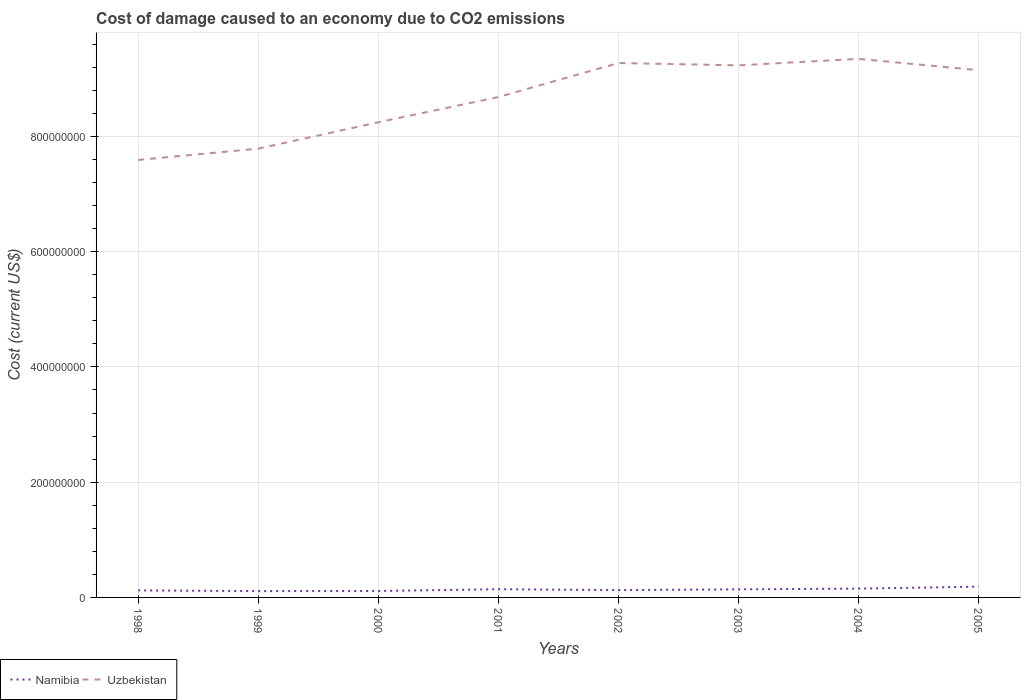How many different coloured lines are there?
Give a very brief answer. 2. Does the line corresponding to Namibia intersect with the line corresponding to Uzbekistan?
Make the answer very short. No. Across all years, what is the maximum cost of damage caused due to CO2 emissisons in Uzbekistan?
Provide a short and direct response. 7.59e+08. What is the total cost of damage caused due to CO2 emissisons in Namibia in the graph?
Provide a short and direct response. -1.26e+06. What is the difference between the highest and the second highest cost of damage caused due to CO2 emissisons in Uzbekistan?
Ensure brevity in your answer.  1.75e+08. What is the difference between the highest and the lowest cost of damage caused due to CO2 emissisons in Namibia?
Provide a succinct answer. 4. Is the cost of damage caused due to CO2 emissisons in Uzbekistan strictly greater than the cost of damage caused due to CO2 emissisons in Namibia over the years?
Your answer should be very brief. No. How many lines are there?
Make the answer very short. 2. How many years are there in the graph?
Offer a very short reply. 8. What is the difference between two consecutive major ticks on the Y-axis?
Ensure brevity in your answer.  2.00e+08. Does the graph contain any zero values?
Provide a short and direct response. No. Does the graph contain grids?
Make the answer very short. Yes. How many legend labels are there?
Your response must be concise. 2. What is the title of the graph?
Provide a succinct answer. Cost of damage caused to an economy due to CO2 emissions. Does "Sint Maarten (Dutch part)" appear as one of the legend labels in the graph?
Make the answer very short. No. What is the label or title of the X-axis?
Give a very brief answer. Years. What is the label or title of the Y-axis?
Provide a short and direct response. Cost (current US$). What is the Cost (current US$) in Namibia in 1998?
Provide a short and direct response. 1.22e+07. What is the Cost (current US$) in Uzbekistan in 1998?
Offer a very short reply. 7.59e+08. What is the Cost (current US$) in Namibia in 1999?
Keep it short and to the point. 1.10e+07. What is the Cost (current US$) in Uzbekistan in 1999?
Offer a terse response. 7.79e+08. What is the Cost (current US$) of Namibia in 2000?
Make the answer very short. 1.12e+07. What is the Cost (current US$) in Uzbekistan in 2000?
Make the answer very short. 8.25e+08. What is the Cost (current US$) of Namibia in 2001?
Keep it short and to the point. 1.42e+07. What is the Cost (current US$) in Uzbekistan in 2001?
Offer a very short reply. 8.68e+08. What is the Cost (current US$) of Namibia in 2002?
Your answer should be very brief. 1.27e+07. What is the Cost (current US$) of Uzbekistan in 2002?
Make the answer very short. 9.27e+08. What is the Cost (current US$) in Namibia in 2003?
Offer a very short reply. 1.40e+07. What is the Cost (current US$) of Uzbekistan in 2003?
Provide a short and direct response. 9.23e+08. What is the Cost (current US$) in Namibia in 2004?
Your answer should be very brief. 1.52e+07. What is the Cost (current US$) of Uzbekistan in 2004?
Provide a succinct answer. 9.35e+08. What is the Cost (current US$) in Namibia in 2005?
Make the answer very short. 1.87e+07. What is the Cost (current US$) in Uzbekistan in 2005?
Offer a very short reply. 9.15e+08. Across all years, what is the maximum Cost (current US$) of Namibia?
Provide a short and direct response. 1.87e+07. Across all years, what is the maximum Cost (current US$) of Uzbekistan?
Your response must be concise. 9.35e+08. Across all years, what is the minimum Cost (current US$) in Namibia?
Your answer should be very brief. 1.10e+07. Across all years, what is the minimum Cost (current US$) of Uzbekistan?
Your response must be concise. 7.59e+08. What is the total Cost (current US$) of Namibia in the graph?
Provide a short and direct response. 1.09e+08. What is the total Cost (current US$) of Uzbekistan in the graph?
Your answer should be compact. 6.93e+09. What is the difference between the Cost (current US$) in Namibia in 1998 and that in 1999?
Keep it short and to the point. 1.26e+06. What is the difference between the Cost (current US$) of Uzbekistan in 1998 and that in 1999?
Keep it short and to the point. -1.96e+07. What is the difference between the Cost (current US$) in Namibia in 1998 and that in 2000?
Your answer should be compact. 1.03e+06. What is the difference between the Cost (current US$) of Uzbekistan in 1998 and that in 2000?
Keep it short and to the point. -6.54e+07. What is the difference between the Cost (current US$) in Namibia in 1998 and that in 2001?
Give a very brief answer. -2.00e+06. What is the difference between the Cost (current US$) of Uzbekistan in 1998 and that in 2001?
Offer a terse response. -1.09e+08. What is the difference between the Cost (current US$) of Namibia in 1998 and that in 2002?
Provide a short and direct response. -5.26e+05. What is the difference between the Cost (current US$) in Uzbekistan in 1998 and that in 2002?
Ensure brevity in your answer.  -1.68e+08. What is the difference between the Cost (current US$) of Namibia in 1998 and that in 2003?
Offer a terse response. -1.78e+06. What is the difference between the Cost (current US$) of Uzbekistan in 1998 and that in 2003?
Offer a very short reply. -1.64e+08. What is the difference between the Cost (current US$) of Namibia in 1998 and that in 2004?
Your answer should be very brief. -3.02e+06. What is the difference between the Cost (current US$) of Uzbekistan in 1998 and that in 2004?
Your answer should be compact. -1.75e+08. What is the difference between the Cost (current US$) in Namibia in 1998 and that in 2005?
Provide a succinct answer. -6.51e+06. What is the difference between the Cost (current US$) of Uzbekistan in 1998 and that in 2005?
Your answer should be very brief. -1.56e+08. What is the difference between the Cost (current US$) in Namibia in 1999 and that in 2000?
Offer a very short reply. -2.31e+05. What is the difference between the Cost (current US$) in Uzbekistan in 1999 and that in 2000?
Your answer should be very brief. -4.57e+07. What is the difference between the Cost (current US$) of Namibia in 1999 and that in 2001?
Offer a terse response. -3.26e+06. What is the difference between the Cost (current US$) in Uzbekistan in 1999 and that in 2001?
Your answer should be very brief. -8.95e+07. What is the difference between the Cost (current US$) of Namibia in 1999 and that in 2002?
Offer a terse response. -1.79e+06. What is the difference between the Cost (current US$) of Uzbekistan in 1999 and that in 2002?
Ensure brevity in your answer.  -1.49e+08. What is the difference between the Cost (current US$) in Namibia in 1999 and that in 2003?
Provide a short and direct response. -3.04e+06. What is the difference between the Cost (current US$) in Uzbekistan in 1999 and that in 2003?
Your answer should be very brief. -1.45e+08. What is the difference between the Cost (current US$) in Namibia in 1999 and that in 2004?
Make the answer very short. -4.28e+06. What is the difference between the Cost (current US$) of Uzbekistan in 1999 and that in 2004?
Ensure brevity in your answer.  -1.56e+08. What is the difference between the Cost (current US$) of Namibia in 1999 and that in 2005?
Your answer should be compact. -7.77e+06. What is the difference between the Cost (current US$) of Uzbekistan in 1999 and that in 2005?
Give a very brief answer. -1.36e+08. What is the difference between the Cost (current US$) of Namibia in 2000 and that in 2001?
Your response must be concise. -3.03e+06. What is the difference between the Cost (current US$) in Uzbekistan in 2000 and that in 2001?
Your answer should be very brief. -4.38e+07. What is the difference between the Cost (current US$) in Namibia in 2000 and that in 2002?
Give a very brief answer. -1.55e+06. What is the difference between the Cost (current US$) in Uzbekistan in 2000 and that in 2002?
Make the answer very short. -1.03e+08. What is the difference between the Cost (current US$) in Namibia in 2000 and that in 2003?
Keep it short and to the point. -2.81e+06. What is the difference between the Cost (current US$) of Uzbekistan in 2000 and that in 2003?
Your response must be concise. -9.88e+07. What is the difference between the Cost (current US$) of Namibia in 2000 and that in 2004?
Offer a terse response. -4.05e+06. What is the difference between the Cost (current US$) in Uzbekistan in 2000 and that in 2004?
Your answer should be very brief. -1.10e+08. What is the difference between the Cost (current US$) of Namibia in 2000 and that in 2005?
Provide a succinct answer. -7.54e+06. What is the difference between the Cost (current US$) of Uzbekistan in 2000 and that in 2005?
Give a very brief answer. -9.04e+07. What is the difference between the Cost (current US$) of Namibia in 2001 and that in 2002?
Give a very brief answer. 1.47e+06. What is the difference between the Cost (current US$) of Uzbekistan in 2001 and that in 2002?
Offer a terse response. -5.90e+07. What is the difference between the Cost (current US$) of Namibia in 2001 and that in 2003?
Keep it short and to the point. 2.14e+05. What is the difference between the Cost (current US$) in Uzbekistan in 2001 and that in 2003?
Offer a very short reply. -5.50e+07. What is the difference between the Cost (current US$) in Namibia in 2001 and that in 2004?
Provide a succinct answer. -1.02e+06. What is the difference between the Cost (current US$) in Uzbekistan in 2001 and that in 2004?
Provide a short and direct response. -6.63e+07. What is the difference between the Cost (current US$) in Namibia in 2001 and that in 2005?
Keep it short and to the point. -4.51e+06. What is the difference between the Cost (current US$) of Uzbekistan in 2001 and that in 2005?
Ensure brevity in your answer.  -4.66e+07. What is the difference between the Cost (current US$) in Namibia in 2002 and that in 2003?
Provide a short and direct response. -1.26e+06. What is the difference between the Cost (current US$) in Uzbekistan in 2002 and that in 2003?
Your response must be concise. 4.01e+06. What is the difference between the Cost (current US$) in Namibia in 2002 and that in 2004?
Offer a terse response. -2.49e+06. What is the difference between the Cost (current US$) in Uzbekistan in 2002 and that in 2004?
Provide a short and direct response. -7.25e+06. What is the difference between the Cost (current US$) of Namibia in 2002 and that in 2005?
Provide a succinct answer. -5.98e+06. What is the difference between the Cost (current US$) in Uzbekistan in 2002 and that in 2005?
Provide a succinct answer. 1.24e+07. What is the difference between the Cost (current US$) in Namibia in 2003 and that in 2004?
Your response must be concise. -1.24e+06. What is the difference between the Cost (current US$) of Uzbekistan in 2003 and that in 2004?
Keep it short and to the point. -1.13e+07. What is the difference between the Cost (current US$) of Namibia in 2003 and that in 2005?
Your answer should be compact. -4.73e+06. What is the difference between the Cost (current US$) of Uzbekistan in 2003 and that in 2005?
Ensure brevity in your answer.  8.36e+06. What is the difference between the Cost (current US$) of Namibia in 2004 and that in 2005?
Keep it short and to the point. -3.49e+06. What is the difference between the Cost (current US$) of Uzbekistan in 2004 and that in 2005?
Ensure brevity in your answer.  1.96e+07. What is the difference between the Cost (current US$) of Namibia in 1998 and the Cost (current US$) of Uzbekistan in 1999?
Keep it short and to the point. -7.67e+08. What is the difference between the Cost (current US$) of Namibia in 1998 and the Cost (current US$) of Uzbekistan in 2000?
Give a very brief answer. -8.12e+08. What is the difference between the Cost (current US$) of Namibia in 1998 and the Cost (current US$) of Uzbekistan in 2001?
Offer a terse response. -8.56e+08. What is the difference between the Cost (current US$) of Namibia in 1998 and the Cost (current US$) of Uzbekistan in 2002?
Offer a very short reply. -9.15e+08. What is the difference between the Cost (current US$) in Namibia in 1998 and the Cost (current US$) in Uzbekistan in 2003?
Your answer should be very brief. -9.11e+08. What is the difference between the Cost (current US$) of Namibia in 1998 and the Cost (current US$) of Uzbekistan in 2004?
Offer a terse response. -9.22e+08. What is the difference between the Cost (current US$) in Namibia in 1998 and the Cost (current US$) in Uzbekistan in 2005?
Your answer should be very brief. -9.03e+08. What is the difference between the Cost (current US$) of Namibia in 1999 and the Cost (current US$) of Uzbekistan in 2000?
Your response must be concise. -8.14e+08. What is the difference between the Cost (current US$) of Namibia in 1999 and the Cost (current US$) of Uzbekistan in 2001?
Provide a short and direct response. -8.57e+08. What is the difference between the Cost (current US$) of Namibia in 1999 and the Cost (current US$) of Uzbekistan in 2002?
Provide a short and direct response. -9.16e+08. What is the difference between the Cost (current US$) in Namibia in 1999 and the Cost (current US$) in Uzbekistan in 2003?
Keep it short and to the point. -9.12e+08. What is the difference between the Cost (current US$) of Namibia in 1999 and the Cost (current US$) of Uzbekistan in 2004?
Offer a very short reply. -9.24e+08. What is the difference between the Cost (current US$) in Namibia in 1999 and the Cost (current US$) in Uzbekistan in 2005?
Provide a short and direct response. -9.04e+08. What is the difference between the Cost (current US$) of Namibia in 2000 and the Cost (current US$) of Uzbekistan in 2001?
Ensure brevity in your answer.  -8.57e+08. What is the difference between the Cost (current US$) of Namibia in 2000 and the Cost (current US$) of Uzbekistan in 2002?
Provide a short and direct response. -9.16e+08. What is the difference between the Cost (current US$) of Namibia in 2000 and the Cost (current US$) of Uzbekistan in 2003?
Provide a succinct answer. -9.12e+08. What is the difference between the Cost (current US$) of Namibia in 2000 and the Cost (current US$) of Uzbekistan in 2004?
Provide a short and direct response. -9.23e+08. What is the difference between the Cost (current US$) of Namibia in 2000 and the Cost (current US$) of Uzbekistan in 2005?
Keep it short and to the point. -9.04e+08. What is the difference between the Cost (current US$) in Namibia in 2001 and the Cost (current US$) in Uzbekistan in 2002?
Provide a short and direct response. -9.13e+08. What is the difference between the Cost (current US$) in Namibia in 2001 and the Cost (current US$) in Uzbekistan in 2003?
Your answer should be compact. -9.09e+08. What is the difference between the Cost (current US$) of Namibia in 2001 and the Cost (current US$) of Uzbekistan in 2004?
Give a very brief answer. -9.20e+08. What is the difference between the Cost (current US$) of Namibia in 2001 and the Cost (current US$) of Uzbekistan in 2005?
Your response must be concise. -9.01e+08. What is the difference between the Cost (current US$) of Namibia in 2002 and the Cost (current US$) of Uzbekistan in 2003?
Your answer should be very brief. -9.11e+08. What is the difference between the Cost (current US$) in Namibia in 2002 and the Cost (current US$) in Uzbekistan in 2004?
Your response must be concise. -9.22e+08. What is the difference between the Cost (current US$) in Namibia in 2002 and the Cost (current US$) in Uzbekistan in 2005?
Your answer should be very brief. -9.02e+08. What is the difference between the Cost (current US$) of Namibia in 2003 and the Cost (current US$) of Uzbekistan in 2004?
Provide a succinct answer. -9.21e+08. What is the difference between the Cost (current US$) of Namibia in 2003 and the Cost (current US$) of Uzbekistan in 2005?
Keep it short and to the point. -9.01e+08. What is the difference between the Cost (current US$) in Namibia in 2004 and the Cost (current US$) in Uzbekistan in 2005?
Keep it short and to the point. -9.00e+08. What is the average Cost (current US$) of Namibia per year?
Keep it short and to the point. 1.37e+07. What is the average Cost (current US$) in Uzbekistan per year?
Offer a terse response. 8.66e+08. In the year 1998, what is the difference between the Cost (current US$) in Namibia and Cost (current US$) in Uzbekistan?
Provide a succinct answer. -7.47e+08. In the year 1999, what is the difference between the Cost (current US$) in Namibia and Cost (current US$) in Uzbekistan?
Your answer should be very brief. -7.68e+08. In the year 2000, what is the difference between the Cost (current US$) in Namibia and Cost (current US$) in Uzbekistan?
Provide a short and direct response. -8.13e+08. In the year 2001, what is the difference between the Cost (current US$) of Namibia and Cost (current US$) of Uzbekistan?
Offer a very short reply. -8.54e+08. In the year 2002, what is the difference between the Cost (current US$) of Namibia and Cost (current US$) of Uzbekistan?
Provide a succinct answer. -9.15e+08. In the year 2003, what is the difference between the Cost (current US$) in Namibia and Cost (current US$) in Uzbekistan?
Provide a short and direct response. -9.09e+08. In the year 2004, what is the difference between the Cost (current US$) of Namibia and Cost (current US$) of Uzbekistan?
Offer a terse response. -9.19e+08. In the year 2005, what is the difference between the Cost (current US$) in Namibia and Cost (current US$) in Uzbekistan?
Offer a terse response. -8.96e+08. What is the ratio of the Cost (current US$) in Namibia in 1998 to that in 1999?
Your answer should be compact. 1.11. What is the ratio of the Cost (current US$) in Uzbekistan in 1998 to that in 1999?
Your response must be concise. 0.97. What is the ratio of the Cost (current US$) in Namibia in 1998 to that in 2000?
Provide a short and direct response. 1.09. What is the ratio of the Cost (current US$) of Uzbekistan in 1998 to that in 2000?
Offer a very short reply. 0.92. What is the ratio of the Cost (current US$) of Namibia in 1998 to that in 2001?
Give a very brief answer. 0.86. What is the ratio of the Cost (current US$) of Uzbekistan in 1998 to that in 2001?
Your response must be concise. 0.87. What is the ratio of the Cost (current US$) in Namibia in 1998 to that in 2002?
Keep it short and to the point. 0.96. What is the ratio of the Cost (current US$) of Uzbekistan in 1998 to that in 2002?
Give a very brief answer. 0.82. What is the ratio of the Cost (current US$) in Namibia in 1998 to that in 2003?
Offer a terse response. 0.87. What is the ratio of the Cost (current US$) in Uzbekistan in 1998 to that in 2003?
Provide a succinct answer. 0.82. What is the ratio of the Cost (current US$) in Namibia in 1998 to that in 2004?
Give a very brief answer. 0.8. What is the ratio of the Cost (current US$) in Uzbekistan in 1998 to that in 2004?
Your answer should be compact. 0.81. What is the ratio of the Cost (current US$) of Namibia in 1998 to that in 2005?
Ensure brevity in your answer.  0.65. What is the ratio of the Cost (current US$) in Uzbekistan in 1998 to that in 2005?
Make the answer very short. 0.83. What is the ratio of the Cost (current US$) of Namibia in 1999 to that in 2000?
Ensure brevity in your answer.  0.98. What is the ratio of the Cost (current US$) of Uzbekistan in 1999 to that in 2000?
Your answer should be very brief. 0.94. What is the ratio of the Cost (current US$) in Namibia in 1999 to that in 2001?
Provide a succinct answer. 0.77. What is the ratio of the Cost (current US$) in Uzbekistan in 1999 to that in 2001?
Provide a short and direct response. 0.9. What is the ratio of the Cost (current US$) of Namibia in 1999 to that in 2002?
Make the answer very short. 0.86. What is the ratio of the Cost (current US$) of Uzbekistan in 1999 to that in 2002?
Keep it short and to the point. 0.84. What is the ratio of the Cost (current US$) in Namibia in 1999 to that in 2003?
Make the answer very short. 0.78. What is the ratio of the Cost (current US$) of Uzbekistan in 1999 to that in 2003?
Provide a short and direct response. 0.84. What is the ratio of the Cost (current US$) of Namibia in 1999 to that in 2004?
Make the answer very short. 0.72. What is the ratio of the Cost (current US$) in Namibia in 1999 to that in 2005?
Offer a terse response. 0.59. What is the ratio of the Cost (current US$) of Uzbekistan in 1999 to that in 2005?
Offer a very short reply. 0.85. What is the ratio of the Cost (current US$) of Namibia in 2000 to that in 2001?
Keep it short and to the point. 0.79. What is the ratio of the Cost (current US$) of Uzbekistan in 2000 to that in 2001?
Keep it short and to the point. 0.95. What is the ratio of the Cost (current US$) in Namibia in 2000 to that in 2002?
Offer a very short reply. 0.88. What is the ratio of the Cost (current US$) of Uzbekistan in 2000 to that in 2002?
Offer a very short reply. 0.89. What is the ratio of the Cost (current US$) of Namibia in 2000 to that in 2003?
Keep it short and to the point. 0.8. What is the ratio of the Cost (current US$) in Uzbekistan in 2000 to that in 2003?
Your answer should be compact. 0.89. What is the ratio of the Cost (current US$) of Namibia in 2000 to that in 2004?
Provide a short and direct response. 0.73. What is the ratio of the Cost (current US$) of Uzbekistan in 2000 to that in 2004?
Provide a short and direct response. 0.88. What is the ratio of the Cost (current US$) of Namibia in 2000 to that in 2005?
Give a very brief answer. 0.6. What is the ratio of the Cost (current US$) of Uzbekistan in 2000 to that in 2005?
Your answer should be very brief. 0.9. What is the ratio of the Cost (current US$) in Namibia in 2001 to that in 2002?
Provide a succinct answer. 1.12. What is the ratio of the Cost (current US$) in Uzbekistan in 2001 to that in 2002?
Offer a terse response. 0.94. What is the ratio of the Cost (current US$) of Namibia in 2001 to that in 2003?
Give a very brief answer. 1.02. What is the ratio of the Cost (current US$) of Uzbekistan in 2001 to that in 2003?
Provide a short and direct response. 0.94. What is the ratio of the Cost (current US$) in Namibia in 2001 to that in 2004?
Your answer should be very brief. 0.93. What is the ratio of the Cost (current US$) in Uzbekistan in 2001 to that in 2004?
Your response must be concise. 0.93. What is the ratio of the Cost (current US$) in Namibia in 2001 to that in 2005?
Your response must be concise. 0.76. What is the ratio of the Cost (current US$) in Uzbekistan in 2001 to that in 2005?
Provide a short and direct response. 0.95. What is the ratio of the Cost (current US$) of Namibia in 2002 to that in 2003?
Give a very brief answer. 0.91. What is the ratio of the Cost (current US$) in Namibia in 2002 to that in 2004?
Your answer should be compact. 0.84. What is the ratio of the Cost (current US$) of Uzbekistan in 2002 to that in 2004?
Make the answer very short. 0.99. What is the ratio of the Cost (current US$) of Namibia in 2002 to that in 2005?
Ensure brevity in your answer.  0.68. What is the ratio of the Cost (current US$) in Uzbekistan in 2002 to that in 2005?
Your response must be concise. 1.01. What is the ratio of the Cost (current US$) in Namibia in 2003 to that in 2004?
Give a very brief answer. 0.92. What is the ratio of the Cost (current US$) in Uzbekistan in 2003 to that in 2004?
Ensure brevity in your answer.  0.99. What is the ratio of the Cost (current US$) in Namibia in 2003 to that in 2005?
Give a very brief answer. 0.75. What is the ratio of the Cost (current US$) of Uzbekistan in 2003 to that in 2005?
Make the answer very short. 1.01. What is the ratio of the Cost (current US$) in Namibia in 2004 to that in 2005?
Ensure brevity in your answer.  0.81. What is the ratio of the Cost (current US$) in Uzbekistan in 2004 to that in 2005?
Give a very brief answer. 1.02. What is the difference between the highest and the second highest Cost (current US$) in Namibia?
Offer a terse response. 3.49e+06. What is the difference between the highest and the second highest Cost (current US$) of Uzbekistan?
Give a very brief answer. 7.25e+06. What is the difference between the highest and the lowest Cost (current US$) of Namibia?
Provide a short and direct response. 7.77e+06. What is the difference between the highest and the lowest Cost (current US$) in Uzbekistan?
Keep it short and to the point. 1.75e+08. 